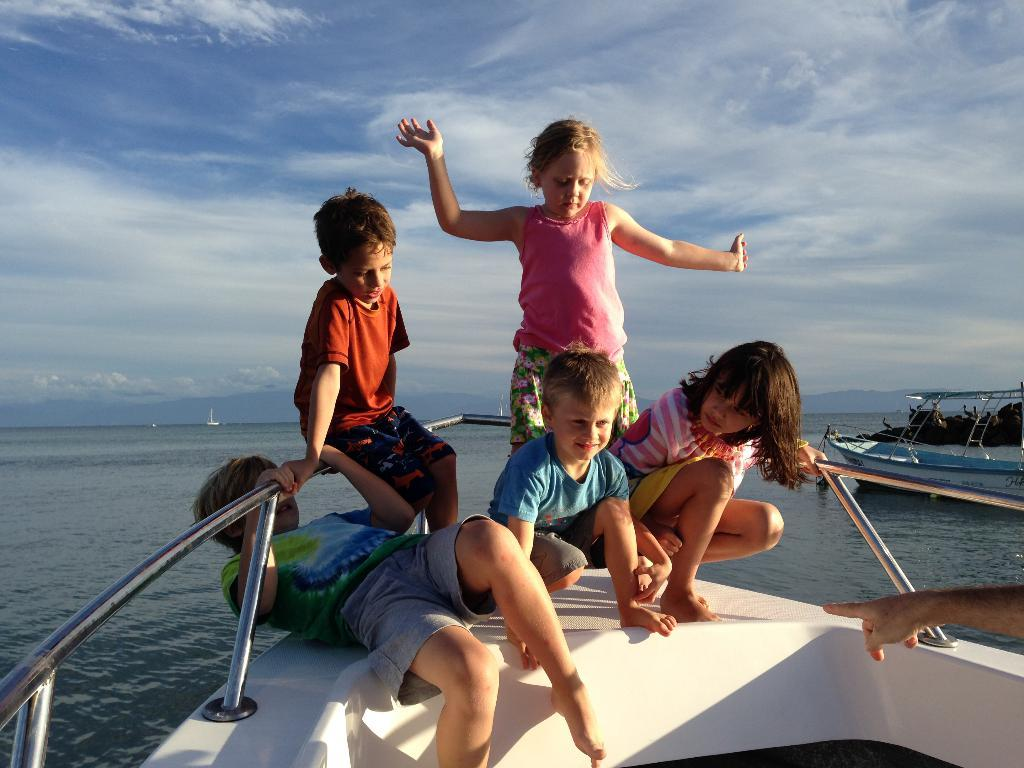What can be seen on the water in the image? There are boats on the water in the image. How many kids are present in the image? There are five kids in the image. What is visible in the background of the image? Sky is visible in the background of the image. What can be seen in the sky? Clouds are present in the sky. What type of steam is coming out of the quartz in the image? There is no steam or quartz present in the image. What trick are the kids performing on the boats in the image? There is no trick being performed by the kids in the image; they are simply present near the boats. 